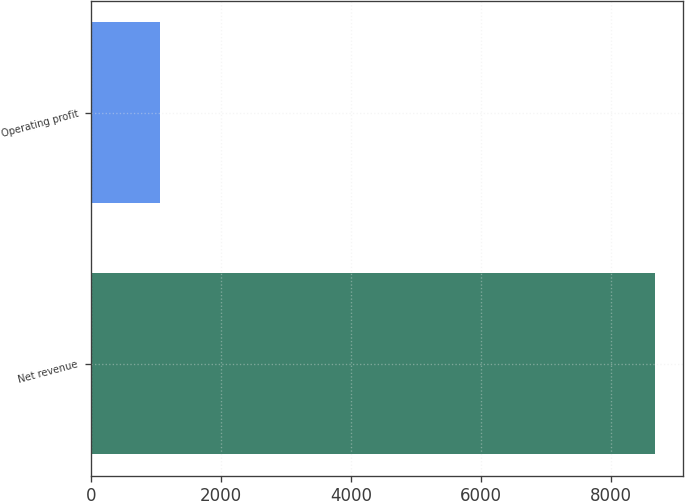<chart> <loc_0><loc_0><loc_500><loc_500><bar_chart><fcel>Net revenue<fcel>Operating profit<nl><fcel>8678<fcel>1061<nl></chart> 